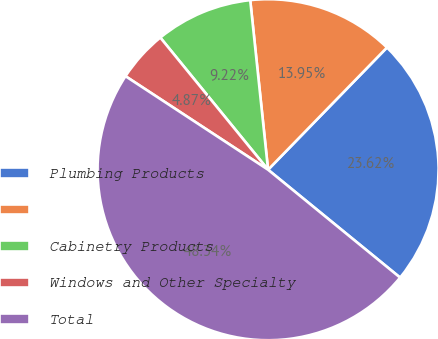Convert chart. <chart><loc_0><loc_0><loc_500><loc_500><pie_chart><fcel>Plumbing Products<fcel>Unnamed: 1<fcel>Cabinetry Products<fcel>Windows and Other Specialty<fcel>Total<nl><fcel>23.62%<fcel>13.95%<fcel>9.22%<fcel>4.87%<fcel>48.34%<nl></chart> 